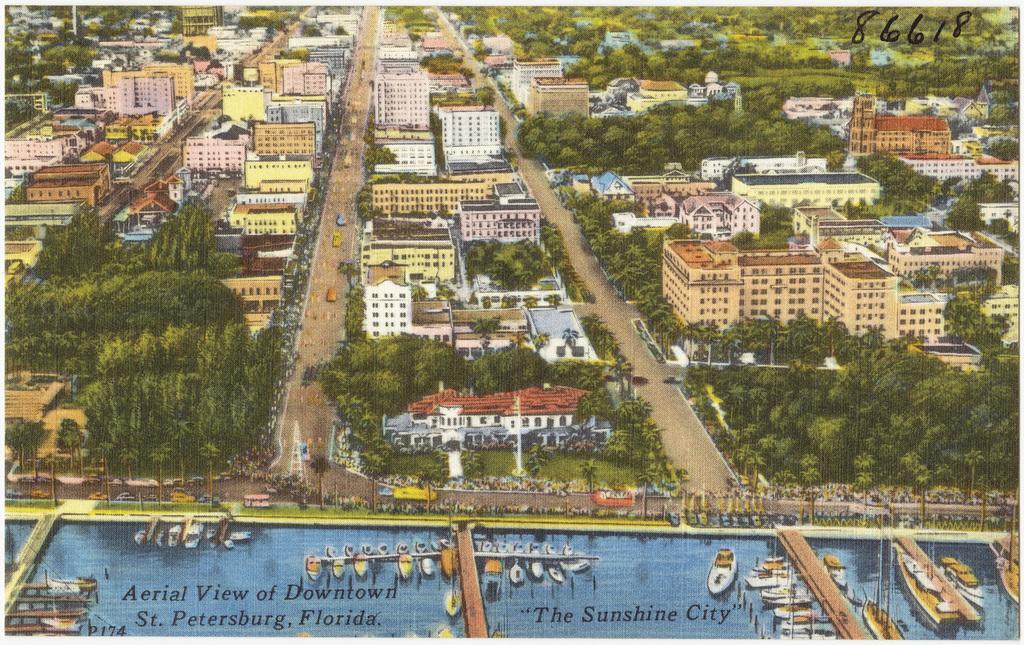Please provide a concise description of this image. In this image, we can see paintings of buildings, trees, poles, vehicles on the road, boards, sheds and we can see some text. 